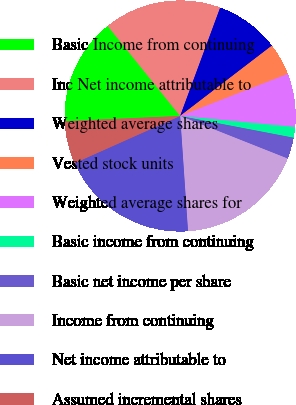Convert chart to OTSL. <chart><loc_0><loc_0><loc_500><loc_500><pie_chart><fcel>Basic Income from continuing<fcel>Inc Net income attributable to<fcel>Weighted average shares<fcel>Vested stock units<fcel>Weighted average shares for<fcel>Basic income from continuing<fcel>Basic net income per share<fcel>Income from continuing<fcel>Net income attributable to<fcel>Assumed incremental shares<nl><fcel>14.93%<fcel>16.42%<fcel>8.96%<fcel>4.48%<fcel>7.46%<fcel>1.49%<fcel>2.99%<fcel>17.91%<fcel>19.4%<fcel>5.97%<nl></chart> 